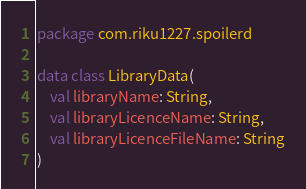<code> <loc_0><loc_0><loc_500><loc_500><_Kotlin_>package com.riku1227.spoilerd

data class LibraryData(
    val libraryName: String,
    val libraryLicenceName: String,
    val libraryLicenceFileName: String
)</code> 